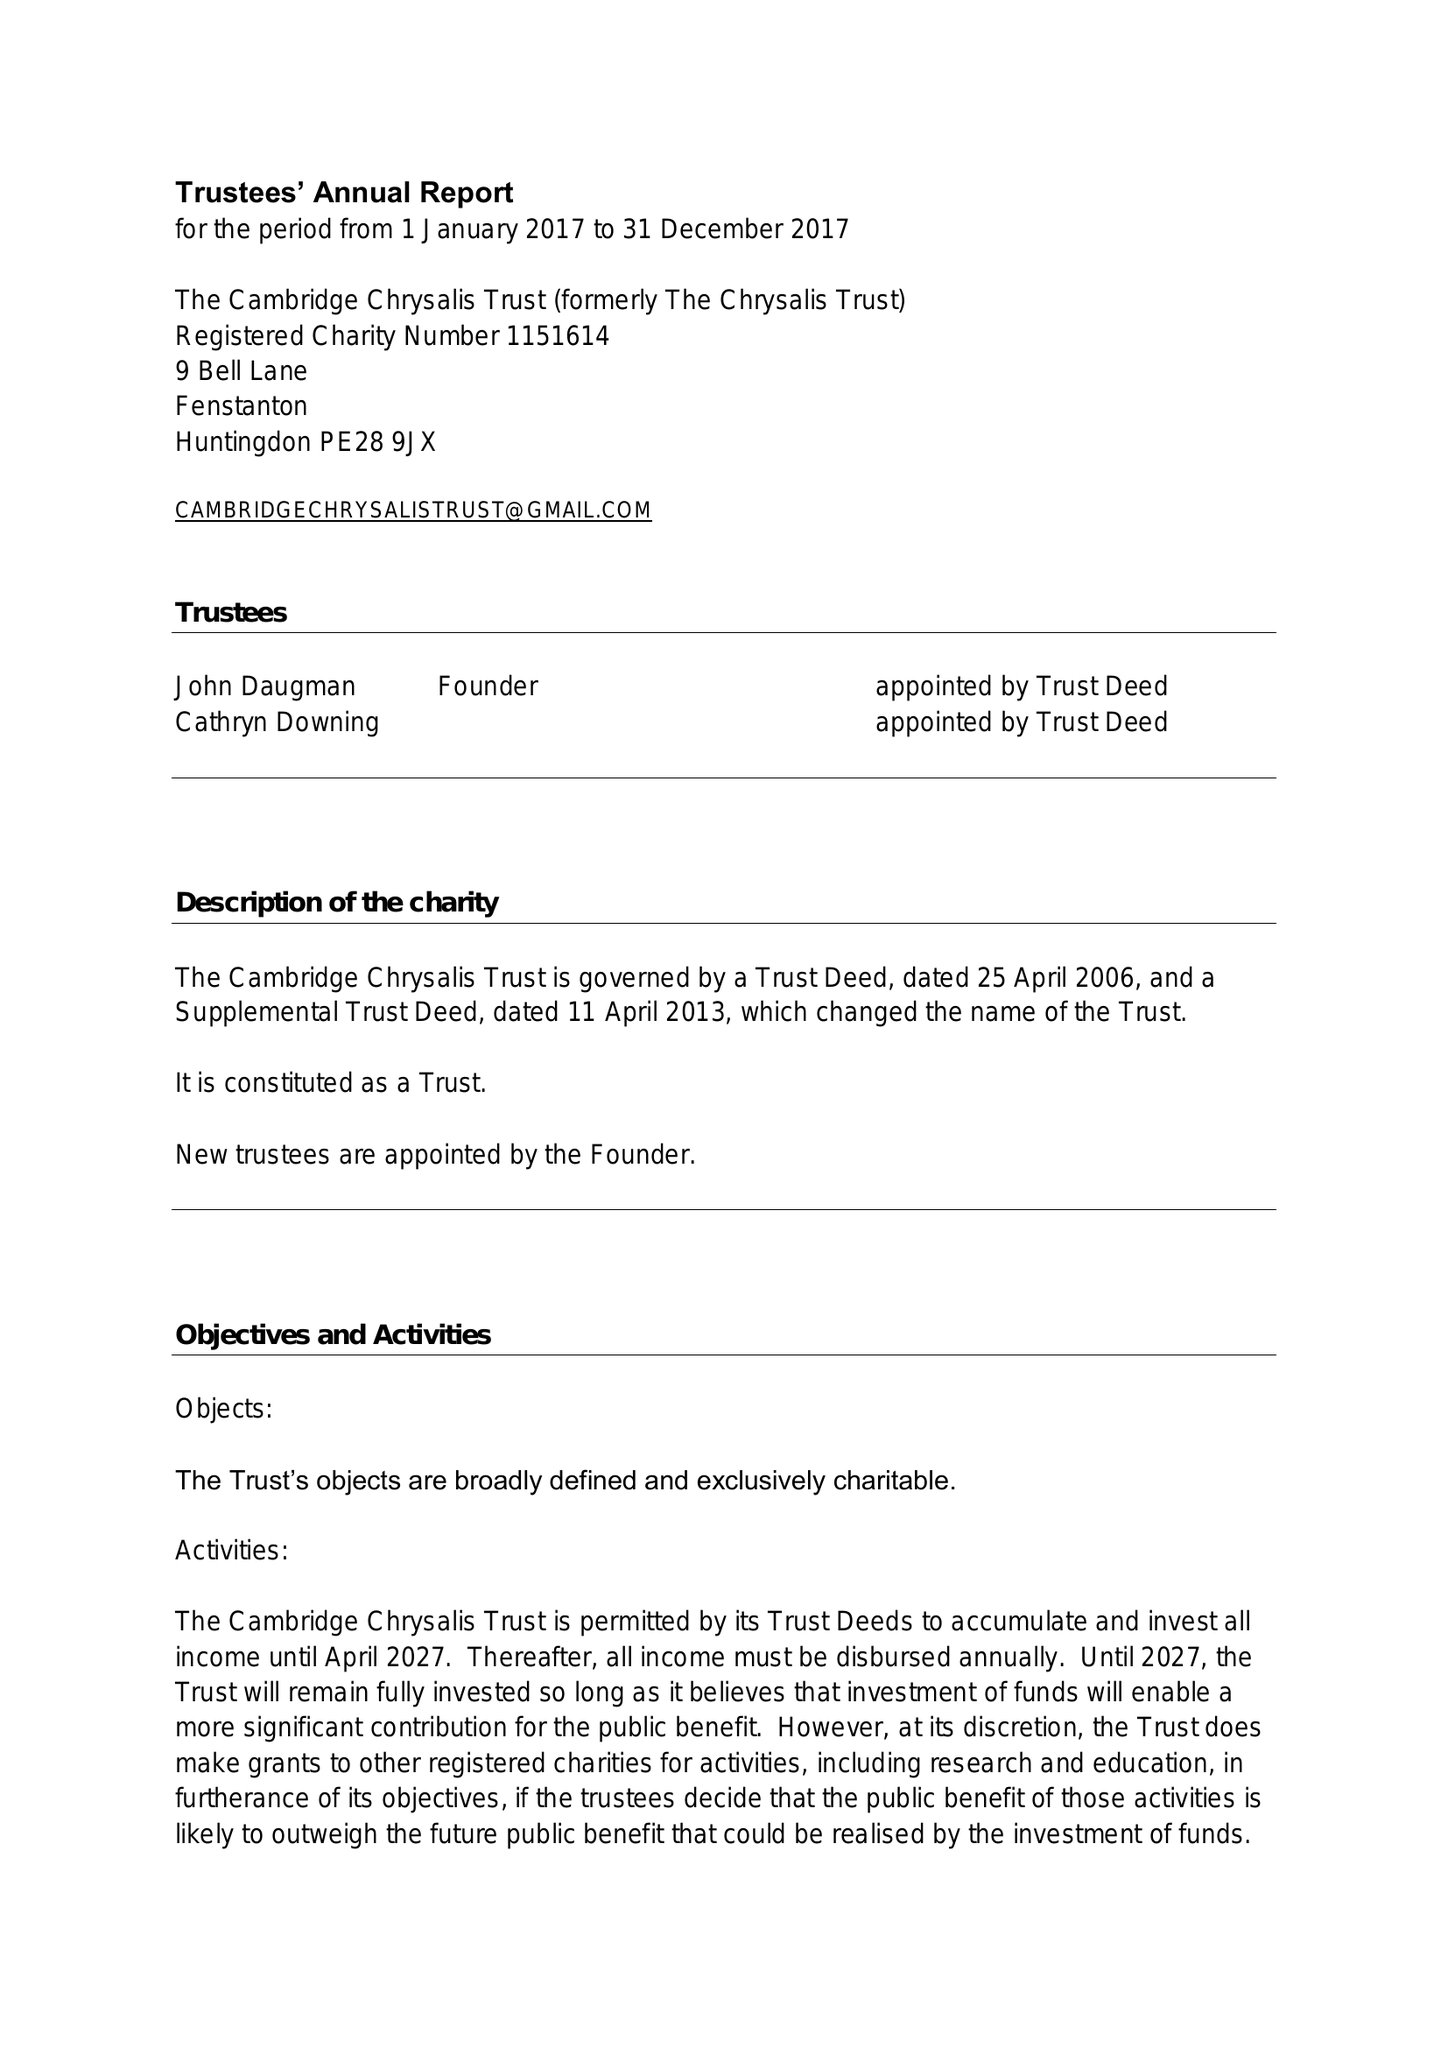What is the value for the income_annually_in_british_pounds?
Answer the question using a single word or phrase. 101427.00 